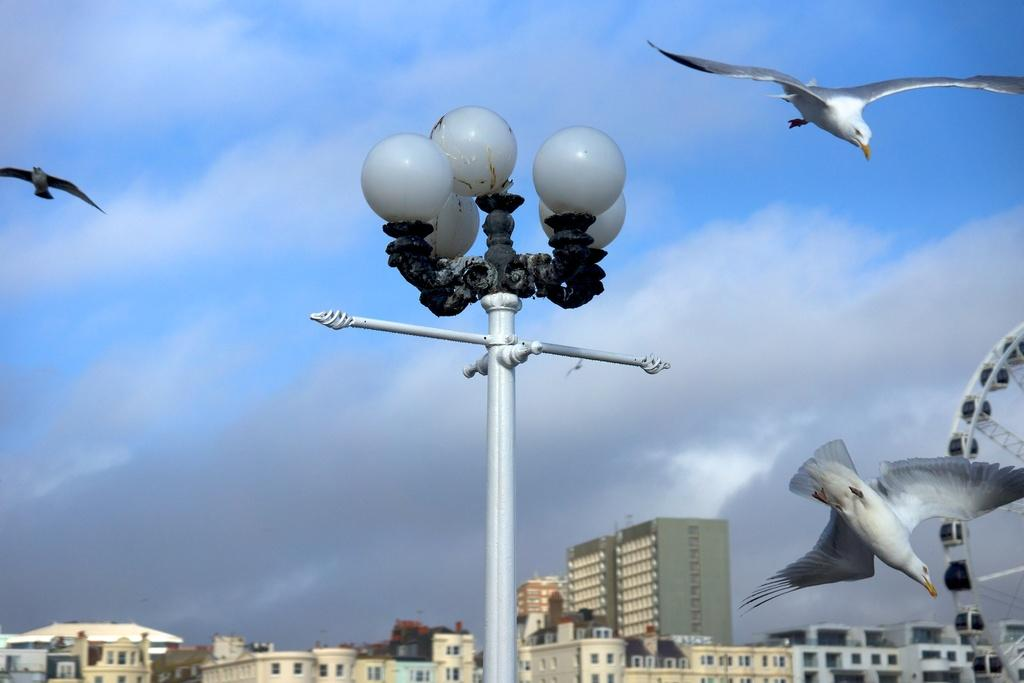What is the main structure in the image? There is a street pole in the image. What type of structures are located at the bottom of the image? There are buildings at the bottom of the image. What amusement ride can be seen in the bottom right of the image? There is a Ferris wheel in the bottom right of the image. What type of animals are visible in the sky? Birds are visible in the sky. What type of stew is being served at the restaurant in the image? There is no restaurant or stew present in the image. How many boys are visible in the image? There are no boys visible in the image. 